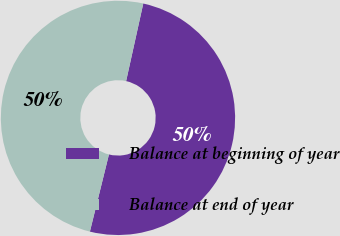Convert chart to OTSL. <chart><loc_0><loc_0><loc_500><loc_500><pie_chart><fcel>Balance at beginning of year<fcel>Balance at end of year<nl><fcel>50.39%<fcel>49.61%<nl></chart> 